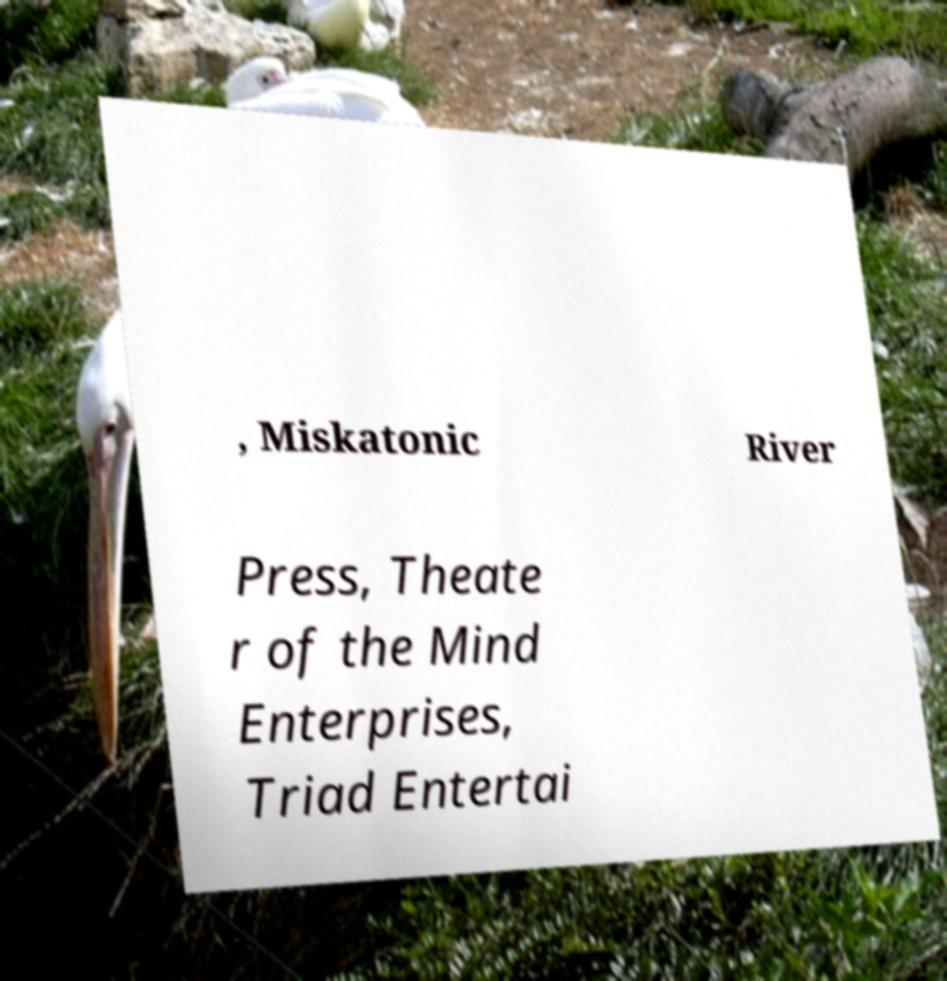Could you extract and type out the text from this image? , Miskatonic River Press, Theate r of the Mind Enterprises, Triad Entertai 